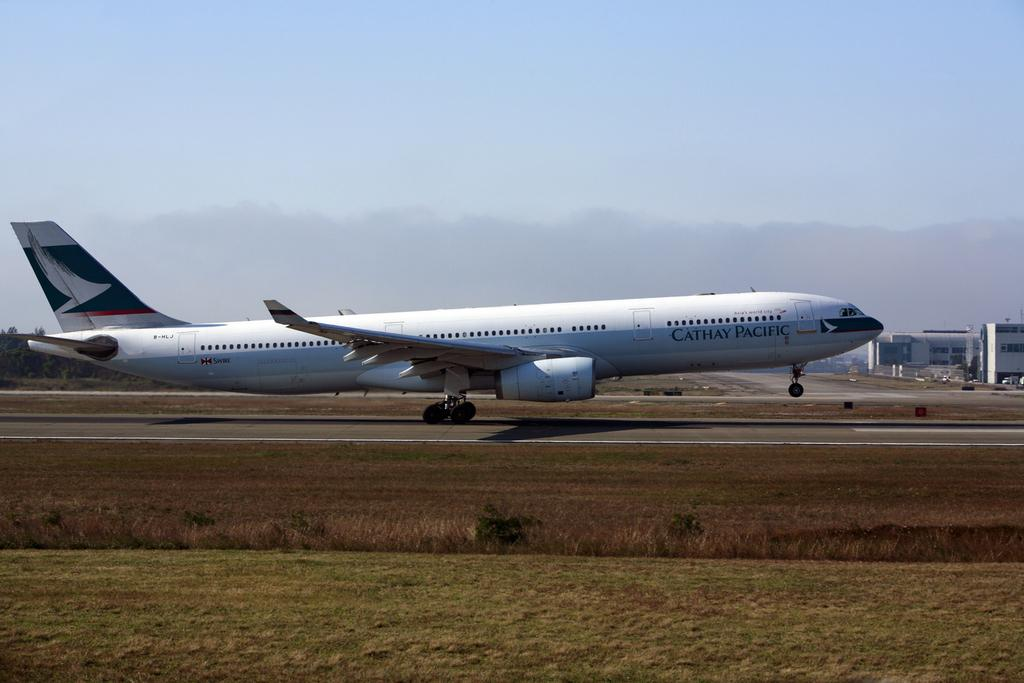What is the main subject of the picture? The main subject of the picture is an airplane. What type of terrain is visible at the bottom of the picture? There is grass at the bottom of the picture. What can be seen in the background of the picture? There are buildings in the background of the picture. What is visible at the top of the picture? The sky is visible at the top of the picture. What type of skirt is being worn by the airplane in the image? There is no skirt present in the image, as the main subject is an airplane. What scientific discoveries are mentioned in the image? There is no mention of scientific discoveries in the image; it primarily features an airplane, grass, buildings, and the sky. 